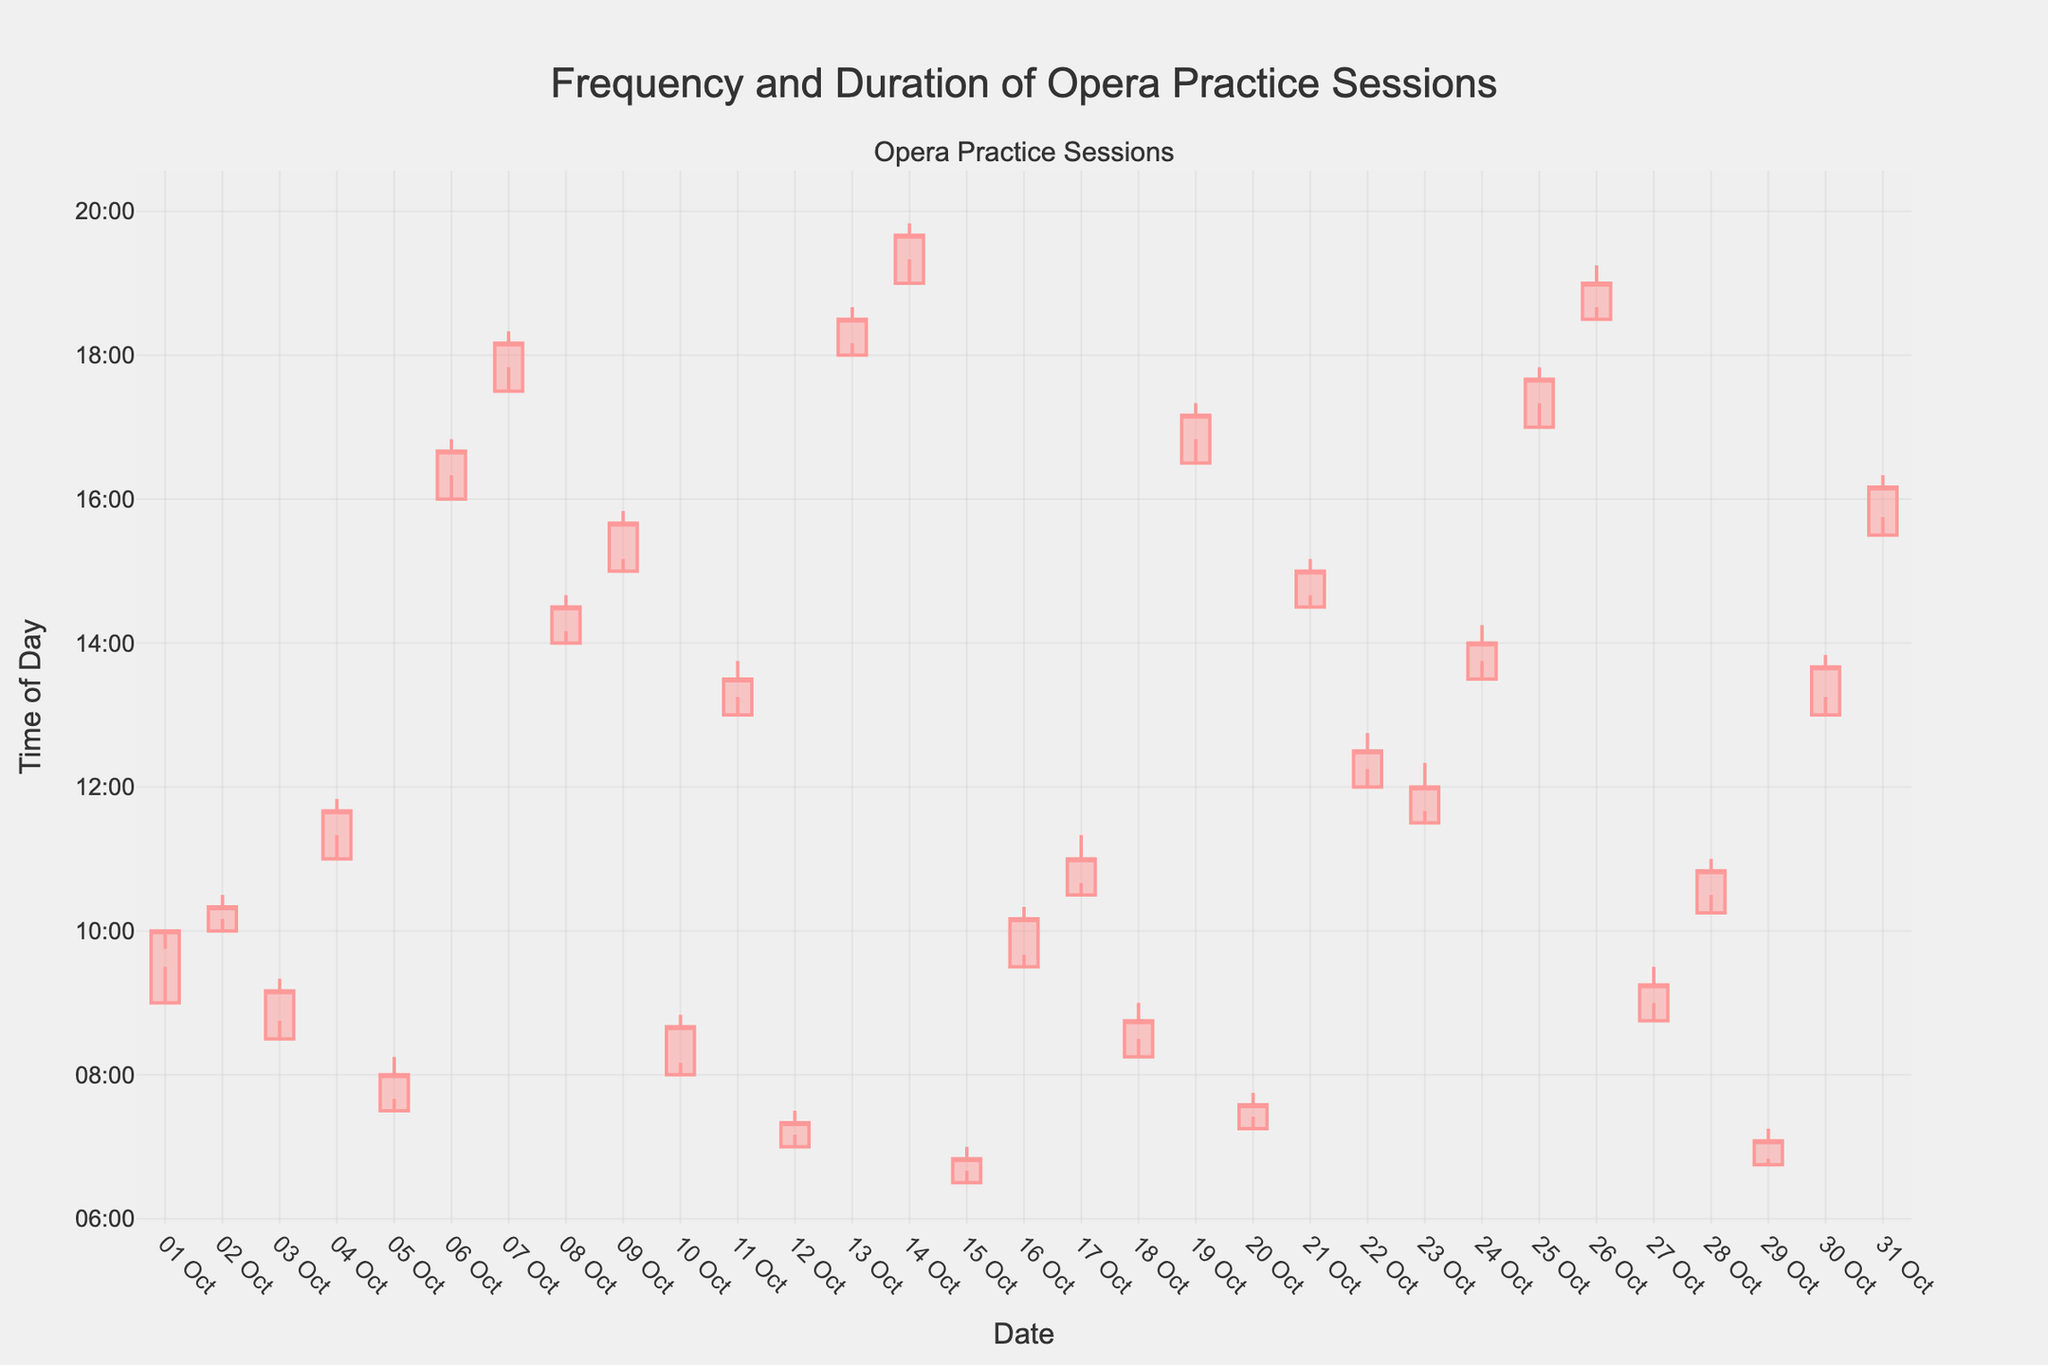What is the title of the figure? The title usually appears at the top of a figure and is meant to provide an overview of what the figure represents. Here, it reads "Frequency and Duration of Opera Practice Sessions".
Answer: Frequency and Duration of Opera Practice Sessions What are the units used on the y-axis? The y-axis typically shows the range of values for the measurements. In this figure, it represents the time of day, marked at intervals from "00:00" to "22:00".
Answer: Time of Day How many days are represented in the figure? The candlestick chart has one candlestick for each day represents. The x-axis is marked with dates of the month from October 1 to October 31, indicating there are 31 days represented.
Answer: 31 On which date was the earliest practice session? To find the earliest practice session, you should look for the candlestick with the lowest point on the y-axis, representing the earliest time of day. The lowest point in the figure is on October 15th, around 6:30 AM.
Answer: October 15 What is the range of practice times on October 6th? On October 6th, the opening time is 16:00, the highest point is 16:50, the lowest point is 16:20, and the closing time is 16:40. The range is from 16:20 to 16:50.
Answer: 16:20 to 16:50 Which day had the longest practice session? The longest practice session corresponds to the day with the largest difference between the highest and lowest time. By observing the lengths of the candlesticks, October 1st had the longest session from 9:00 to 10:00, one hour.
Answer: October 1 Which practice session ended closest to noon? To find the session that ended closest to 12:00 PM, look for the candlestick where the closing value is closest to the corresponding time. On October 22nd, the practice session ended around 12:30 PM.
Answer: October 22 What is the median close time for the practice sessions? To find the median close time, list all the closing times in minutes, sort them, and find the middle value. The sorted closing times in minutes are: [410, 420, 435, 440, 445, 465, 470, 475, 480, 500, 510, 520, 525, 525, 525, 540, 555, 560, 560, 580, 595, 600, 715, 730, 805, 820, 940, 1010, 1080]. The middle value is 535, which corresponds to 8:55 AM.
Answer: 8:55 AM On which date did the practice session take place the latest? The latest practice session is indicated by the highest value on the y-axis, corresponding to the highest point of any candlestick. This was on October 14th around 19:50 PM.
Answer: October 14 